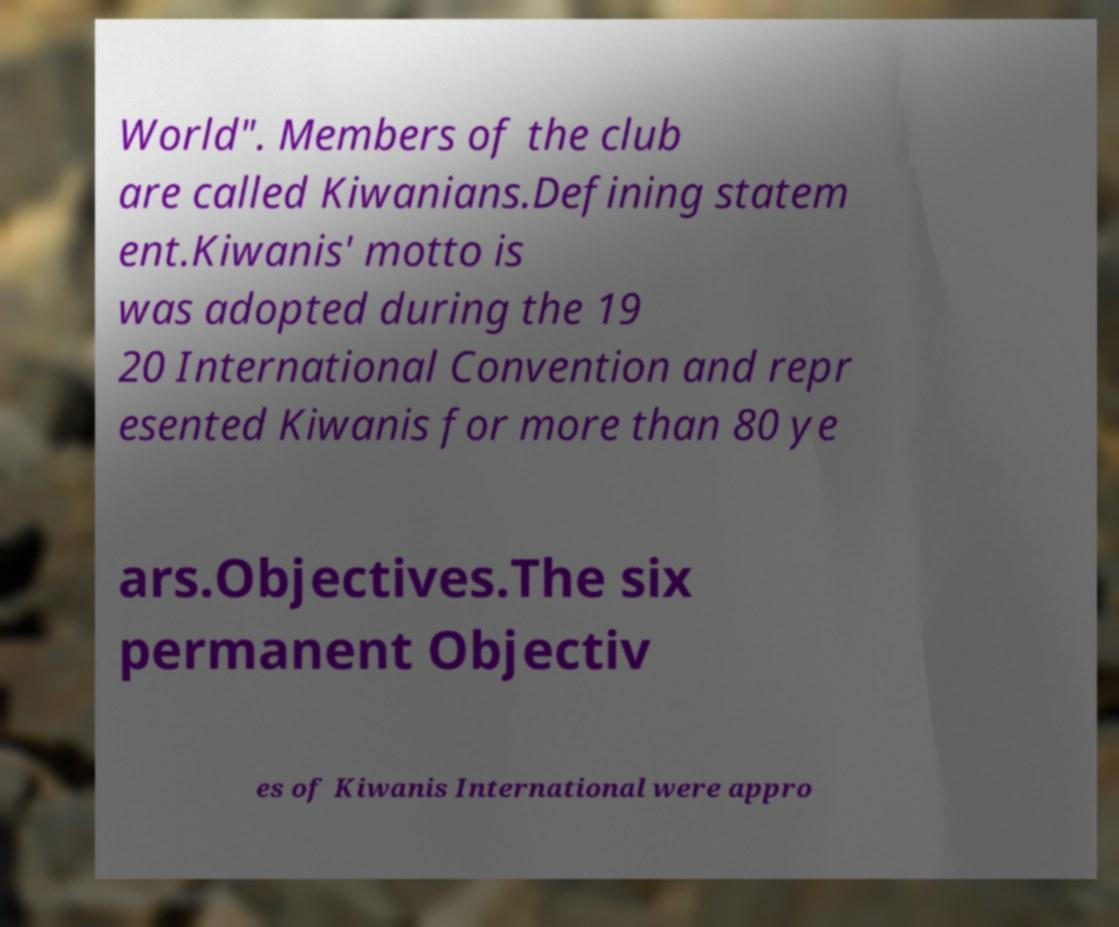There's text embedded in this image that I need extracted. Can you transcribe it verbatim? World". Members of the club are called Kiwanians.Defining statem ent.Kiwanis' motto is was adopted during the 19 20 International Convention and repr esented Kiwanis for more than 80 ye ars.Objectives.The six permanent Objectiv es of Kiwanis International were appro 